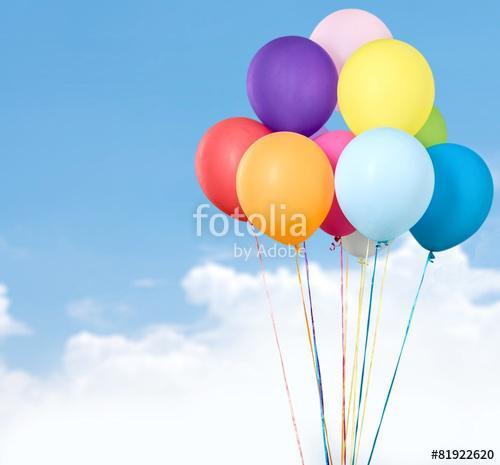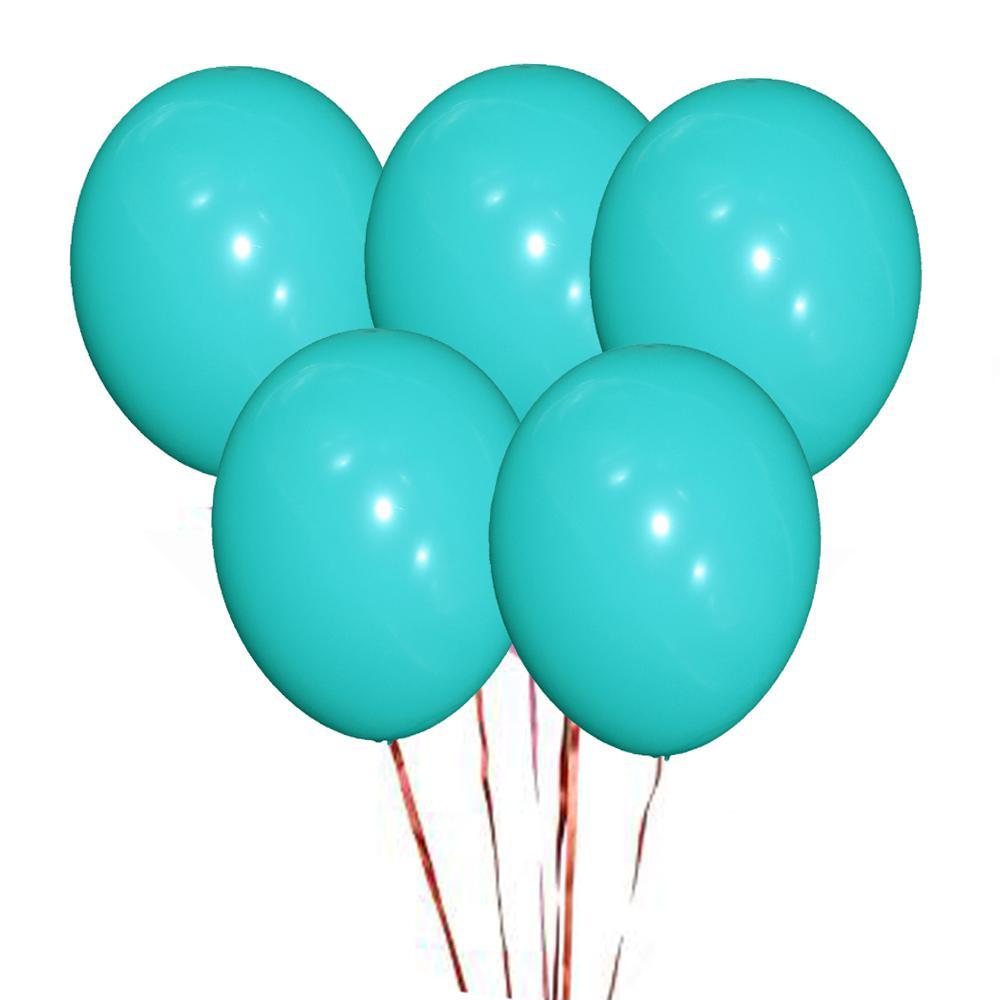The first image is the image on the left, the second image is the image on the right. Assess this claim about the two images: "In at least one image there are hundreds of balloons being released into the sky.". Correct or not? Answer yes or no. No. 